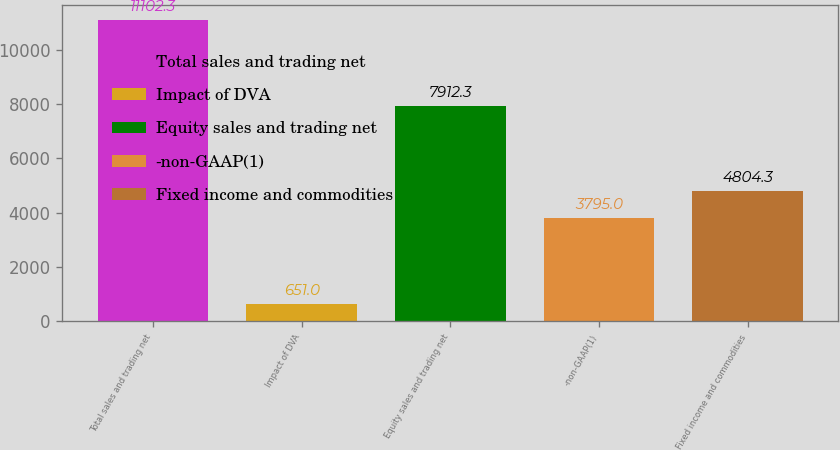Convert chart. <chart><loc_0><loc_0><loc_500><loc_500><bar_chart><fcel>Total sales and trading net<fcel>Impact of DVA<fcel>Equity sales and trading net<fcel>-non-GAAP(1)<fcel>Fixed income and commodities<nl><fcel>11102.3<fcel>651<fcel>7912.3<fcel>3795<fcel>4804.3<nl></chart> 